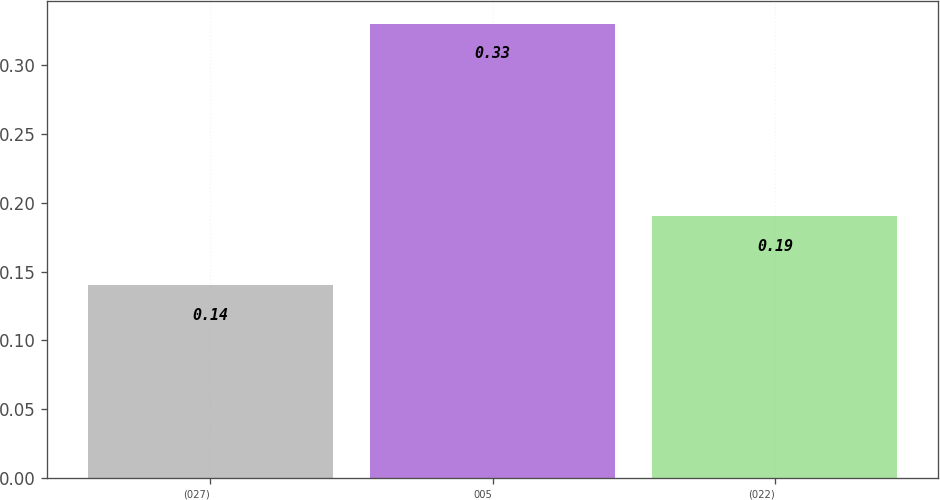Convert chart. <chart><loc_0><loc_0><loc_500><loc_500><bar_chart><fcel>(027)<fcel>005<fcel>(022)<nl><fcel>0.14<fcel>0.33<fcel>0.19<nl></chart> 